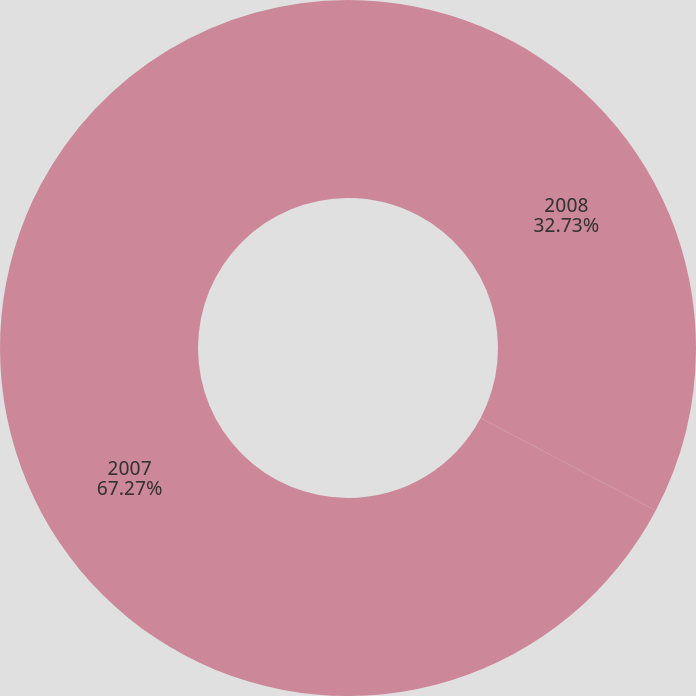<chart> <loc_0><loc_0><loc_500><loc_500><pie_chart><fcel>2008<fcel>2007<nl><fcel>32.73%<fcel>67.27%<nl></chart> 